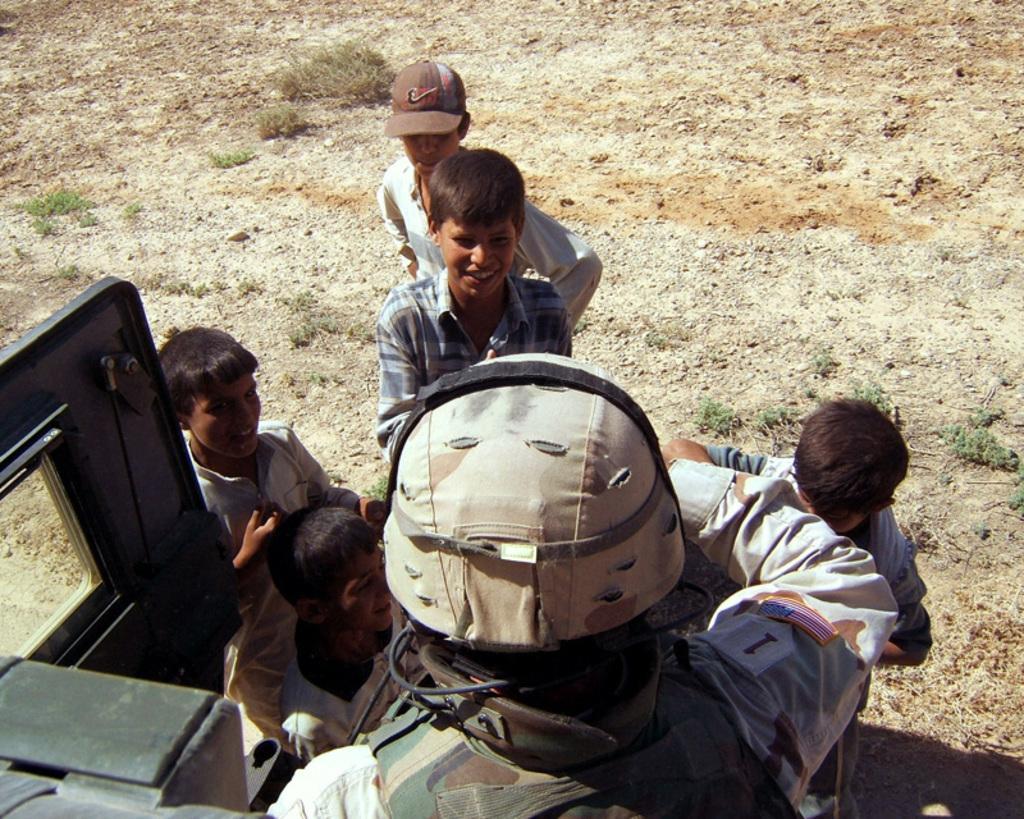Can you describe this image briefly? In this image, there are a few people. We can see the ground. We can see some grass. We can also see an object on the right. 